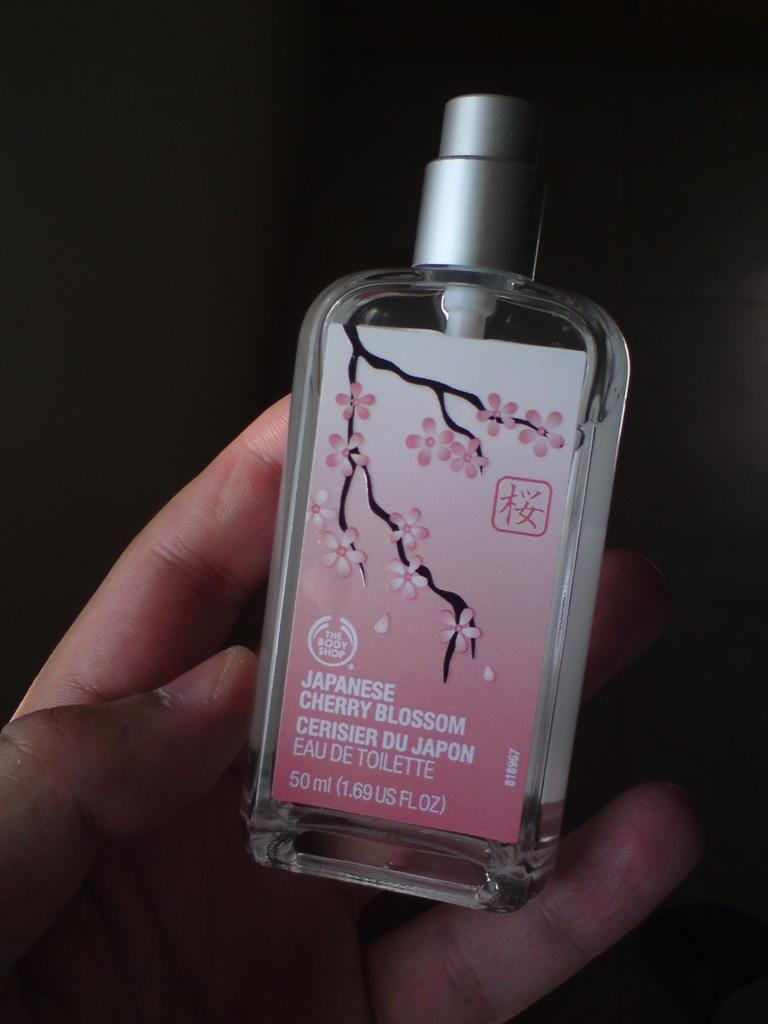What is being held by the person's hand in the image? There is a person's hand holding a bottle in the image. What can be seen on the bottle? The bottle has a label on it. What information is provided on the label? There is text on the label. How would you describe the overall appearance of the image? The background of the image is dark. What type of bike can be seen in the image? There is no bike present in the image. Can you tell me how many donkeys are visible in the image? There are no donkeys present in the image. 